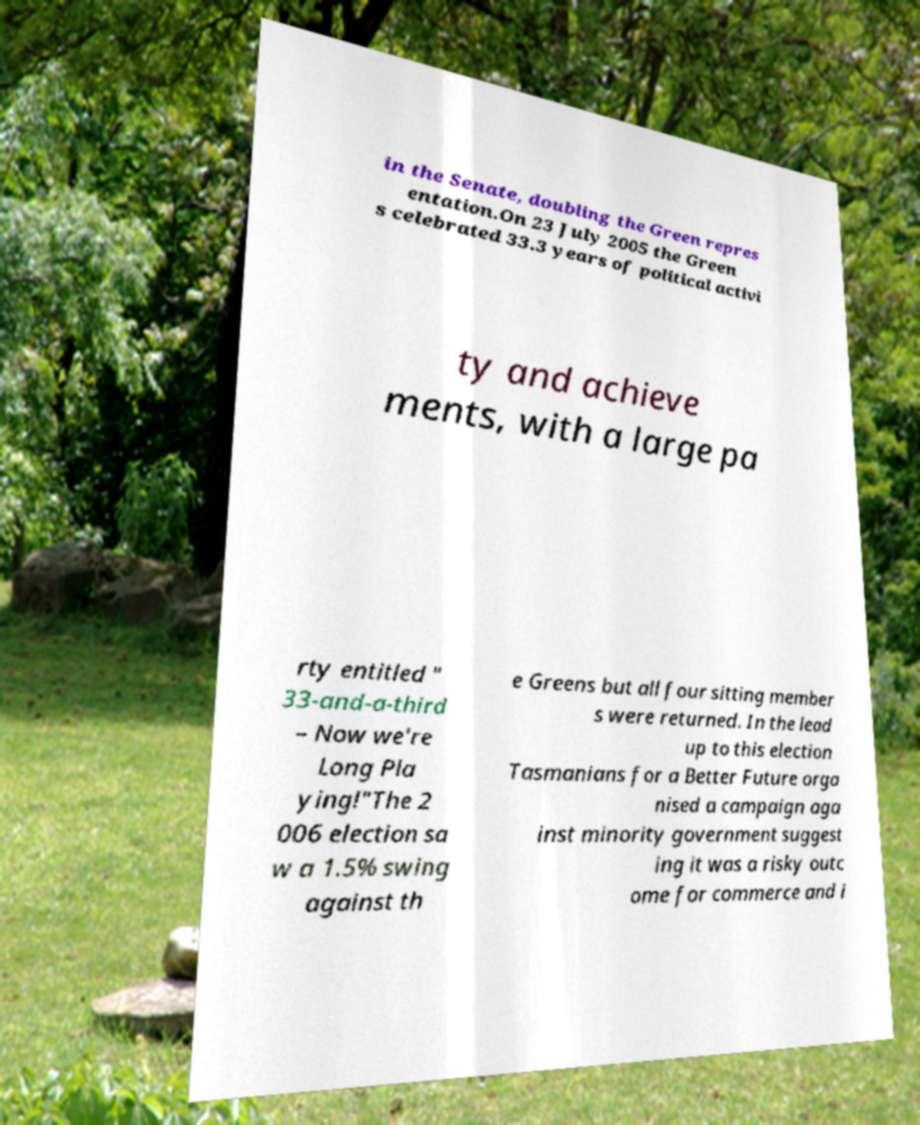For documentation purposes, I need the text within this image transcribed. Could you provide that? in the Senate, doubling the Green repres entation.On 23 July 2005 the Green s celebrated 33.3 years of political activi ty and achieve ments, with a large pa rty entitled " 33-and-a-third – Now we're Long Pla ying!"The 2 006 election sa w a 1.5% swing against th e Greens but all four sitting member s were returned. In the lead up to this election Tasmanians for a Better Future orga nised a campaign aga inst minority government suggest ing it was a risky outc ome for commerce and i 